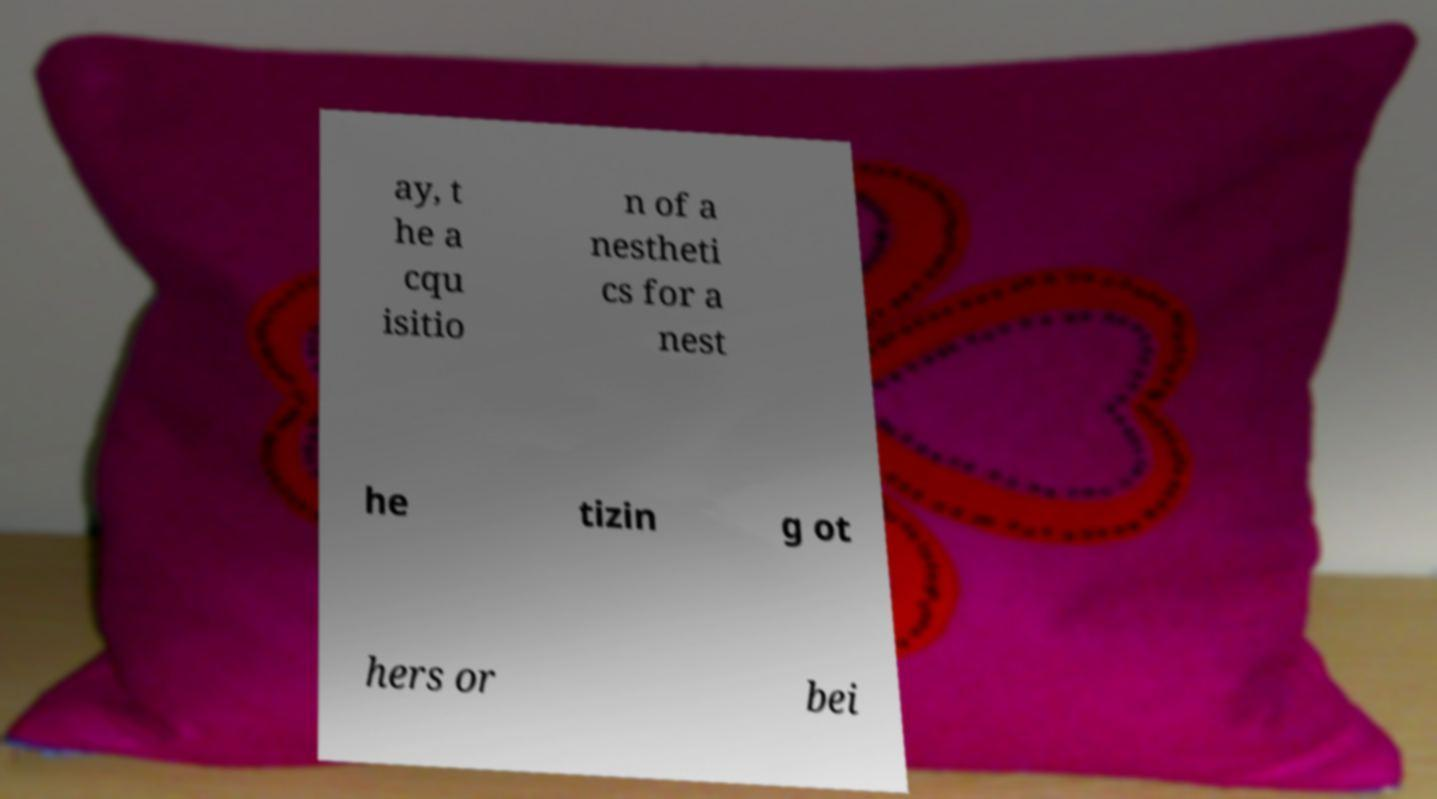Can you accurately transcribe the text from the provided image for me? ay, t he a cqu isitio n of a nestheti cs for a nest he tizin g ot hers or bei 